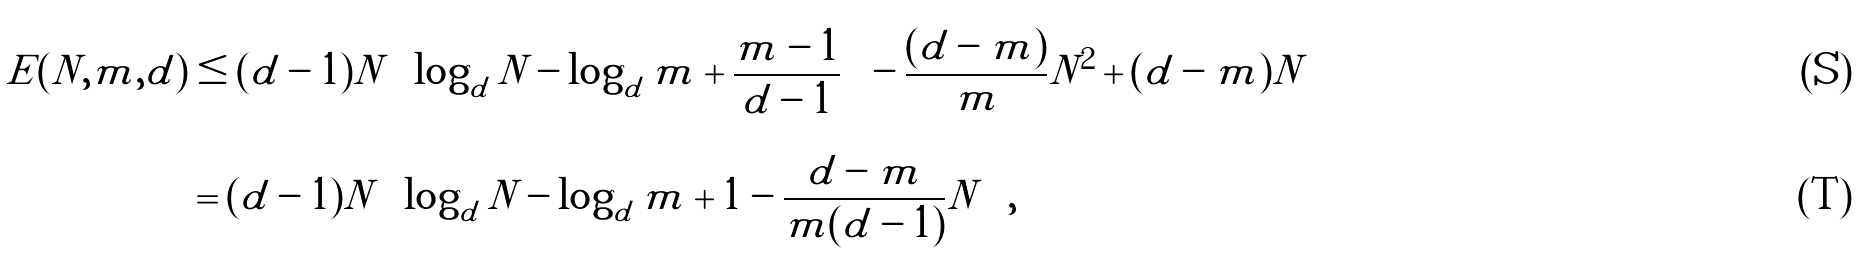<formula> <loc_0><loc_0><loc_500><loc_500>E ( N , m , d ) & \leq ( d - 1 ) N \left [ \log _ { d } N - \log _ { d } m + \frac { m - 1 } { d - 1 } \right ] - \frac { ( d - m ) } { m } N ^ { 2 } + ( d - m ) N \\ & = ( d - 1 ) N \left [ \log _ { d } N - \log _ { d } m + 1 - \frac { d - m } { m ( d - 1 ) } N \right ] ,</formula> 